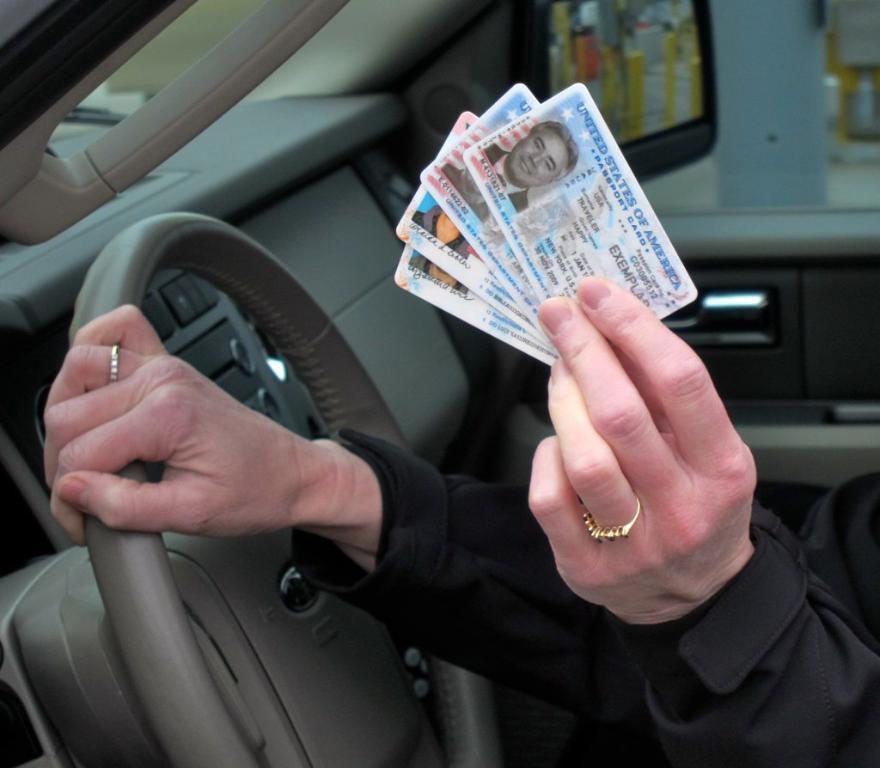In one or two sentences, can you explain what this image depicts? In this picture we can see hands of a person holding cards and steering. We can see glass window, through glass window we can see side mirror. 